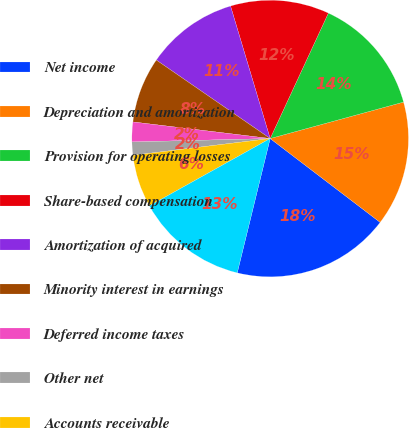<chart> <loc_0><loc_0><loc_500><loc_500><pie_chart><fcel>Net income<fcel>Depreciation and amortization<fcel>Provision for operating losses<fcel>Share-based compensation<fcel>Amortization of acquired<fcel>Minority interest in earnings<fcel>Deferred income taxes<fcel>Other net<fcel>Accounts receivable<fcel>Claims receivable<nl><fcel>18.46%<fcel>14.61%<fcel>13.84%<fcel>11.54%<fcel>10.77%<fcel>7.69%<fcel>2.31%<fcel>1.54%<fcel>6.16%<fcel>13.08%<nl></chart> 